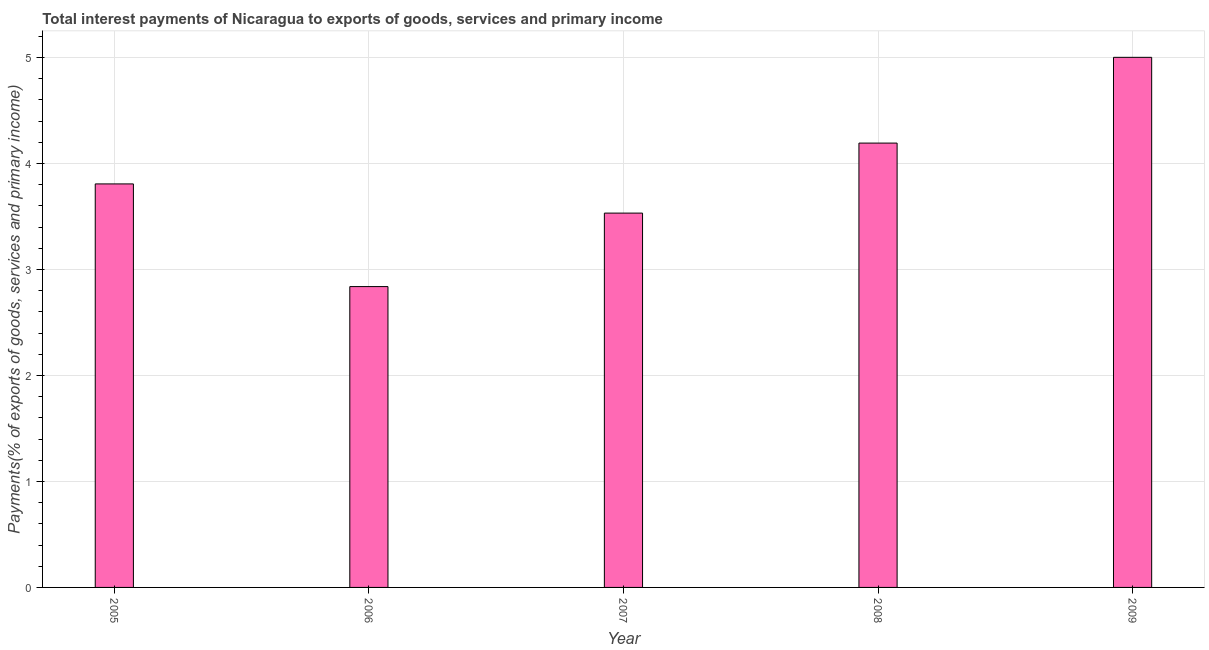Does the graph contain grids?
Make the answer very short. Yes. What is the title of the graph?
Provide a succinct answer. Total interest payments of Nicaragua to exports of goods, services and primary income. What is the label or title of the Y-axis?
Your answer should be compact. Payments(% of exports of goods, services and primary income). What is the total interest payments on external debt in 2006?
Offer a very short reply. 2.84. Across all years, what is the maximum total interest payments on external debt?
Give a very brief answer. 5. Across all years, what is the minimum total interest payments on external debt?
Provide a succinct answer. 2.84. What is the sum of the total interest payments on external debt?
Give a very brief answer. 19.37. What is the difference between the total interest payments on external debt in 2007 and 2009?
Offer a very short reply. -1.47. What is the average total interest payments on external debt per year?
Your answer should be very brief. 3.88. What is the median total interest payments on external debt?
Ensure brevity in your answer.  3.81. In how many years, is the total interest payments on external debt greater than 1.6 %?
Your answer should be compact. 5. Do a majority of the years between 2009 and 2007 (inclusive) have total interest payments on external debt greater than 0.2 %?
Give a very brief answer. Yes. What is the ratio of the total interest payments on external debt in 2005 to that in 2007?
Offer a very short reply. 1.08. Is the difference between the total interest payments on external debt in 2007 and 2009 greater than the difference between any two years?
Offer a terse response. No. What is the difference between the highest and the second highest total interest payments on external debt?
Your response must be concise. 0.81. Is the sum of the total interest payments on external debt in 2007 and 2008 greater than the maximum total interest payments on external debt across all years?
Provide a succinct answer. Yes. What is the difference between the highest and the lowest total interest payments on external debt?
Provide a succinct answer. 2.16. In how many years, is the total interest payments on external debt greater than the average total interest payments on external debt taken over all years?
Make the answer very short. 2. How many bars are there?
Give a very brief answer. 5. What is the difference between two consecutive major ticks on the Y-axis?
Ensure brevity in your answer.  1. Are the values on the major ticks of Y-axis written in scientific E-notation?
Provide a succinct answer. No. What is the Payments(% of exports of goods, services and primary income) of 2005?
Offer a very short reply. 3.81. What is the Payments(% of exports of goods, services and primary income) of 2006?
Keep it short and to the point. 2.84. What is the Payments(% of exports of goods, services and primary income) in 2007?
Give a very brief answer. 3.53. What is the Payments(% of exports of goods, services and primary income) in 2008?
Provide a short and direct response. 4.19. What is the Payments(% of exports of goods, services and primary income) in 2009?
Keep it short and to the point. 5. What is the difference between the Payments(% of exports of goods, services and primary income) in 2005 and 2006?
Your response must be concise. 0.97. What is the difference between the Payments(% of exports of goods, services and primary income) in 2005 and 2007?
Your answer should be compact. 0.28. What is the difference between the Payments(% of exports of goods, services and primary income) in 2005 and 2008?
Make the answer very short. -0.39. What is the difference between the Payments(% of exports of goods, services and primary income) in 2005 and 2009?
Your answer should be compact. -1.19. What is the difference between the Payments(% of exports of goods, services and primary income) in 2006 and 2007?
Ensure brevity in your answer.  -0.69. What is the difference between the Payments(% of exports of goods, services and primary income) in 2006 and 2008?
Give a very brief answer. -1.35. What is the difference between the Payments(% of exports of goods, services and primary income) in 2006 and 2009?
Your response must be concise. -2.16. What is the difference between the Payments(% of exports of goods, services and primary income) in 2007 and 2008?
Your response must be concise. -0.66. What is the difference between the Payments(% of exports of goods, services and primary income) in 2007 and 2009?
Keep it short and to the point. -1.47. What is the difference between the Payments(% of exports of goods, services and primary income) in 2008 and 2009?
Ensure brevity in your answer.  -0.81. What is the ratio of the Payments(% of exports of goods, services and primary income) in 2005 to that in 2006?
Provide a short and direct response. 1.34. What is the ratio of the Payments(% of exports of goods, services and primary income) in 2005 to that in 2007?
Offer a very short reply. 1.08. What is the ratio of the Payments(% of exports of goods, services and primary income) in 2005 to that in 2008?
Your answer should be compact. 0.91. What is the ratio of the Payments(% of exports of goods, services and primary income) in 2005 to that in 2009?
Your answer should be compact. 0.76. What is the ratio of the Payments(% of exports of goods, services and primary income) in 2006 to that in 2007?
Your response must be concise. 0.8. What is the ratio of the Payments(% of exports of goods, services and primary income) in 2006 to that in 2008?
Ensure brevity in your answer.  0.68. What is the ratio of the Payments(% of exports of goods, services and primary income) in 2006 to that in 2009?
Your answer should be compact. 0.57. What is the ratio of the Payments(% of exports of goods, services and primary income) in 2007 to that in 2008?
Your answer should be compact. 0.84. What is the ratio of the Payments(% of exports of goods, services and primary income) in 2007 to that in 2009?
Make the answer very short. 0.71. What is the ratio of the Payments(% of exports of goods, services and primary income) in 2008 to that in 2009?
Your response must be concise. 0.84. 